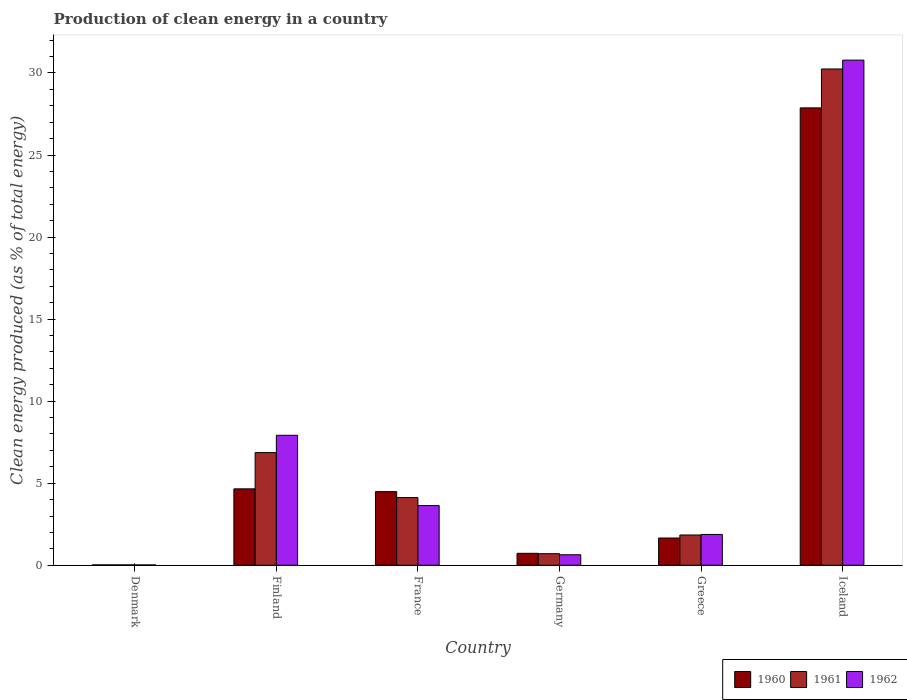How many different coloured bars are there?
Your answer should be very brief. 3. Are the number of bars on each tick of the X-axis equal?
Your response must be concise. Yes. What is the percentage of clean energy produced in 1960 in Germany?
Make the answer very short. 0.73. Across all countries, what is the maximum percentage of clean energy produced in 1960?
Your answer should be compact. 27.87. Across all countries, what is the minimum percentage of clean energy produced in 1960?
Ensure brevity in your answer.  0.02. What is the total percentage of clean energy produced in 1961 in the graph?
Keep it short and to the point. 43.81. What is the difference between the percentage of clean energy produced in 1960 in Finland and that in Iceland?
Your response must be concise. -23.22. What is the difference between the percentage of clean energy produced in 1962 in Greece and the percentage of clean energy produced in 1960 in Denmark?
Your response must be concise. 1.85. What is the average percentage of clean energy produced in 1960 per country?
Give a very brief answer. 6.57. What is the difference between the percentage of clean energy produced of/in 1962 and percentage of clean energy produced of/in 1961 in Denmark?
Give a very brief answer. -0. What is the ratio of the percentage of clean energy produced in 1962 in Denmark to that in Greece?
Give a very brief answer. 0.01. Is the percentage of clean energy produced in 1961 in Denmark less than that in France?
Keep it short and to the point. Yes. What is the difference between the highest and the second highest percentage of clean energy produced in 1962?
Provide a short and direct response. -27.15. What is the difference between the highest and the lowest percentage of clean energy produced in 1962?
Provide a short and direct response. 30.76. Is the sum of the percentage of clean energy produced in 1962 in Denmark and Iceland greater than the maximum percentage of clean energy produced in 1961 across all countries?
Offer a terse response. Yes. What does the 1st bar from the right in Greece represents?
Your answer should be compact. 1962. Is it the case that in every country, the sum of the percentage of clean energy produced in 1961 and percentage of clean energy produced in 1960 is greater than the percentage of clean energy produced in 1962?
Provide a short and direct response. Yes. Are all the bars in the graph horizontal?
Offer a very short reply. No. Are the values on the major ticks of Y-axis written in scientific E-notation?
Offer a terse response. No. Where does the legend appear in the graph?
Provide a short and direct response. Bottom right. How many legend labels are there?
Your answer should be very brief. 3. What is the title of the graph?
Offer a very short reply. Production of clean energy in a country. What is the label or title of the Y-axis?
Ensure brevity in your answer.  Clean energy produced (as % of total energy). What is the Clean energy produced (as % of total energy) in 1960 in Denmark?
Ensure brevity in your answer.  0.02. What is the Clean energy produced (as % of total energy) of 1961 in Denmark?
Your answer should be very brief. 0.02. What is the Clean energy produced (as % of total energy) in 1962 in Denmark?
Offer a very short reply. 0.02. What is the Clean energy produced (as % of total energy) of 1960 in Finland?
Keep it short and to the point. 4.66. What is the Clean energy produced (as % of total energy) of 1961 in Finland?
Offer a very short reply. 6.87. What is the Clean energy produced (as % of total energy) in 1962 in Finland?
Your answer should be compact. 7.92. What is the Clean energy produced (as % of total energy) of 1960 in France?
Make the answer very short. 4.49. What is the Clean energy produced (as % of total energy) of 1961 in France?
Your response must be concise. 4.12. What is the Clean energy produced (as % of total energy) in 1962 in France?
Your answer should be very brief. 3.64. What is the Clean energy produced (as % of total energy) of 1960 in Germany?
Offer a very short reply. 0.73. What is the Clean energy produced (as % of total energy) in 1961 in Germany?
Offer a terse response. 0.7. What is the Clean energy produced (as % of total energy) of 1962 in Germany?
Keep it short and to the point. 0.64. What is the Clean energy produced (as % of total energy) in 1960 in Greece?
Your answer should be very brief. 1.66. What is the Clean energy produced (as % of total energy) in 1961 in Greece?
Give a very brief answer. 1.84. What is the Clean energy produced (as % of total energy) in 1962 in Greece?
Offer a terse response. 1.88. What is the Clean energy produced (as % of total energy) of 1960 in Iceland?
Your answer should be compact. 27.87. What is the Clean energy produced (as % of total energy) in 1961 in Iceland?
Offer a very short reply. 30.24. What is the Clean energy produced (as % of total energy) of 1962 in Iceland?
Offer a very short reply. 30.78. Across all countries, what is the maximum Clean energy produced (as % of total energy) of 1960?
Offer a terse response. 27.87. Across all countries, what is the maximum Clean energy produced (as % of total energy) in 1961?
Provide a short and direct response. 30.24. Across all countries, what is the maximum Clean energy produced (as % of total energy) in 1962?
Ensure brevity in your answer.  30.78. Across all countries, what is the minimum Clean energy produced (as % of total energy) of 1960?
Your answer should be very brief. 0.02. Across all countries, what is the minimum Clean energy produced (as % of total energy) of 1961?
Provide a succinct answer. 0.02. Across all countries, what is the minimum Clean energy produced (as % of total energy) of 1962?
Give a very brief answer. 0.02. What is the total Clean energy produced (as % of total energy) of 1960 in the graph?
Make the answer very short. 39.43. What is the total Clean energy produced (as % of total energy) of 1961 in the graph?
Provide a short and direct response. 43.81. What is the total Clean energy produced (as % of total energy) of 1962 in the graph?
Make the answer very short. 44.88. What is the difference between the Clean energy produced (as % of total energy) of 1960 in Denmark and that in Finland?
Give a very brief answer. -4.63. What is the difference between the Clean energy produced (as % of total energy) in 1961 in Denmark and that in Finland?
Your response must be concise. -6.84. What is the difference between the Clean energy produced (as % of total energy) in 1962 in Denmark and that in Finland?
Make the answer very short. -7.9. What is the difference between the Clean energy produced (as % of total energy) in 1960 in Denmark and that in France?
Ensure brevity in your answer.  -4.46. What is the difference between the Clean energy produced (as % of total energy) of 1961 in Denmark and that in France?
Your answer should be compact. -4.1. What is the difference between the Clean energy produced (as % of total energy) of 1962 in Denmark and that in France?
Give a very brief answer. -3.62. What is the difference between the Clean energy produced (as % of total energy) in 1960 in Denmark and that in Germany?
Your answer should be very brief. -0.7. What is the difference between the Clean energy produced (as % of total energy) of 1961 in Denmark and that in Germany?
Provide a short and direct response. -0.68. What is the difference between the Clean energy produced (as % of total energy) in 1962 in Denmark and that in Germany?
Make the answer very short. -0.62. What is the difference between the Clean energy produced (as % of total energy) in 1960 in Denmark and that in Greece?
Ensure brevity in your answer.  -1.64. What is the difference between the Clean energy produced (as % of total energy) of 1961 in Denmark and that in Greece?
Keep it short and to the point. -1.82. What is the difference between the Clean energy produced (as % of total energy) in 1962 in Denmark and that in Greece?
Provide a short and direct response. -1.86. What is the difference between the Clean energy produced (as % of total energy) in 1960 in Denmark and that in Iceland?
Offer a terse response. -27.85. What is the difference between the Clean energy produced (as % of total energy) in 1961 in Denmark and that in Iceland?
Your answer should be compact. -30.22. What is the difference between the Clean energy produced (as % of total energy) in 1962 in Denmark and that in Iceland?
Your answer should be compact. -30.76. What is the difference between the Clean energy produced (as % of total energy) of 1960 in Finland and that in France?
Your response must be concise. 0.17. What is the difference between the Clean energy produced (as % of total energy) in 1961 in Finland and that in France?
Provide a short and direct response. 2.74. What is the difference between the Clean energy produced (as % of total energy) in 1962 in Finland and that in France?
Provide a short and direct response. 4.28. What is the difference between the Clean energy produced (as % of total energy) in 1960 in Finland and that in Germany?
Provide a succinct answer. 3.93. What is the difference between the Clean energy produced (as % of total energy) in 1961 in Finland and that in Germany?
Offer a terse response. 6.16. What is the difference between the Clean energy produced (as % of total energy) in 1962 in Finland and that in Germany?
Your response must be concise. 7.28. What is the difference between the Clean energy produced (as % of total energy) of 1960 in Finland and that in Greece?
Your response must be concise. 3. What is the difference between the Clean energy produced (as % of total energy) in 1961 in Finland and that in Greece?
Your answer should be very brief. 5.02. What is the difference between the Clean energy produced (as % of total energy) in 1962 in Finland and that in Greece?
Provide a succinct answer. 6.04. What is the difference between the Clean energy produced (as % of total energy) of 1960 in Finland and that in Iceland?
Your answer should be very brief. -23.22. What is the difference between the Clean energy produced (as % of total energy) in 1961 in Finland and that in Iceland?
Offer a terse response. -23.38. What is the difference between the Clean energy produced (as % of total energy) of 1962 in Finland and that in Iceland?
Keep it short and to the point. -22.86. What is the difference between the Clean energy produced (as % of total energy) in 1960 in France and that in Germany?
Your response must be concise. 3.76. What is the difference between the Clean energy produced (as % of total energy) of 1961 in France and that in Germany?
Ensure brevity in your answer.  3.42. What is the difference between the Clean energy produced (as % of total energy) in 1962 in France and that in Germany?
Your answer should be very brief. 3. What is the difference between the Clean energy produced (as % of total energy) of 1960 in France and that in Greece?
Provide a succinct answer. 2.83. What is the difference between the Clean energy produced (as % of total energy) in 1961 in France and that in Greece?
Provide a succinct answer. 2.28. What is the difference between the Clean energy produced (as % of total energy) in 1962 in France and that in Greece?
Your response must be concise. 1.76. What is the difference between the Clean energy produced (as % of total energy) of 1960 in France and that in Iceland?
Give a very brief answer. -23.39. What is the difference between the Clean energy produced (as % of total energy) of 1961 in France and that in Iceland?
Your answer should be compact. -26.12. What is the difference between the Clean energy produced (as % of total energy) of 1962 in France and that in Iceland?
Offer a very short reply. -27.15. What is the difference between the Clean energy produced (as % of total energy) of 1960 in Germany and that in Greece?
Your answer should be very brief. -0.93. What is the difference between the Clean energy produced (as % of total energy) in 1961 in Germany and that in Greece?
Your answer should be very brief. -1.14. What is the difference between the Clean energy produced (as % of total energy) of 1962 in Germany and that in Greece?
Provide a succinct answer. -1.24. What is the difference between the Clean energy produced (as % of total energy) in 1960 in Germany and that in Iceland?
Your answer should be compact. -27.14. What is the difference between the Clean energy produced (as % of total energy) in 1961 in Germany and that in Iceland?
Offer a very short reply. -29.54. What is the difference between the Clean energy produced (as % of total energy) in 1962 in Germany and that in Iceland?
Ensure brevity in your answer.  -30.14. What is the difference between the Clean energy produced (as % of total energy) of 1960 in Greece and that in Iceland?
Ensure brevity in your answer.  -26.21. What is the difference between the Clean energy produced (as % of total energy) of 1961 in Greece and that in Iceland?
Provide a short and direct response. -28.4. What is the difference between the Clean energy produced (as % of total energy) of 1962 in Greece and that in Iceland?
Offer a terse response. -28.9. What is the difference between the Clean energy produced (as % of total energy) of 1960 in Denmark and the Clean energy produced (as % of total energy) of 1961 in Finland?
Your answer should be compact. -6.84. What is the difference between the Clean energy produced (as % of total energy) in 1960 in Denmark and the Clean energy produced (as % of total energy) in 1962 in Finland?
Your response must be concise. -7.9. What is the difference between the Clean energy produced (as % of total energy) in 1961 in Denmark and the Clean energy produced (as % of total energy) in 1962 in Finland?
Give a very brief answer. -7.9. What is the difference between the Clean energy produced (as % of total energy) in 1960 in Denmark and the Clean energy produced (as % of total energy) in 1961 in France?
Provide a short and direct response. -4.1. What is the difference between the Clean energy produced (as % of total energy) of 1960 in Denmark and the Clean energy produced (as % of total energy) of 1962 in France?
Make the answer very short. -3.61. What is the difference between the Clean energy produced (as % of total energy) of 1961 in Denmark and the Clean energy produced (as % of total energy) of 1962 in France?
Give a very brief answer. -3.61. What is the difference between the Clean energy produced (as % of total energy) in 1960 in Denmark and the Clean energy produced (as % of total energy) in 1961 in Germany?
Offer a very short reply. -0.68. What is the difference between the Clean energy produced (as % of total energy) of 1960 in Denmark and the Clean energy produced (as % of total energy) of 1962 in Germany?
Offer a very short reply. -0.62. What is the difference between the Clean energy produced (as % of total energy) of 1961 in Denmark and the Clean energy produced (as % of total energy) of 1962 in Germany?
Offer a very short reply. -0.62. What is the difference between the Clean energy produced (as % of total energy) of 1960 in Denmark and the Clean energy produced (as % of total energy) of 1961 in Greece?
Offer a terse response. -1.82. What is the difference between the Clean energy produced (as % of total energy) of 1960 in Denmark and the Clean energy produced (as % of total energy) of 1962 in Greece?
Provide a succinct answer. -1.85. What is the difference between the Clean energy produced (as % of total energy) in 1961 in Denmark and the Clean energy produced (as % of total energy) in 1962 in Greece?
Offer a terse response. -1.85. What is the difference between the Clean energy produced (as % of total energy) of 1960 in Denmark and the Clean energy produced (as % of total energy) of 1961 in Iceland?
Offer a very short reply. -30.22. What is the difference between the Clean energy produced (as % of total energy) of 1960 in Denmark and the Clean energy produced (as % of total energy) of 1962 in Iceland?
Ensure brevity in your answer.  -30.76. What is the difference between the Clean energy produced (as % of total energy) of 1961 in Denmark and the Clean energy produced (as % of total energy) of 1962 in Iceland?
Make the answer very short. -30.76. What is the difference between the Clean energy produced (as % of total energy) in 1960 in Finland and the Clean energy produced (as % of total energy) in 1961 in France?
Offer a terse response. 0.53. What is the difference between the Clean energy produced (as % of total energy) in 1960 in Finland and the Clean energy produced (as % of total energy) in 1962 in France?
Offer a very short reply. 1.02. What is the difference between the Clean energy produced (as % of total energy) in 1961 in Finland and the Clean energy produced (as % of total energy) in 1962 in France?
Provide a short and direct response. 3.23. What is the difference between the Clean energy produced (as % of total energy) of 1960 in Finland and the Clean energy produced (as % of total energy) of 1961 in Germany?
Offer a very short reply. 3.95. What is the difference between the Clean energy produced (as % of total energy) of 1960 in Finland and the Clean energy produced (as % of total energy) of 1962 in Germany?
Offer a very short reply. 4.02. What is the difference between the Clean energy produced (as % of total energy) in 1961 in Finland and the Clean energy produced (as % of total energy) in 1962 in Germany?
Keep it short and to the point. 6.23. What is the difference between the Clean energy produced (as % of total energy) in 1960 in Finland and the Clean energy produced (as % of total energy) in 1961 in Greece?
Make the answer very short. 2.81. What is the difference between the Clean energy produced (as % of total energy) in 1960 in Finland and the Clean energy produced (as % of total energy) in 1962 in Greece?
Ensure brevity in your answer.  2.78. What is the difference between the Clean energy produced (as % of total energy) in 1961 in Finland and the Clean energy produced (as % of total energy) in 1962 in Greece?
Your response must be concise. 4.99. What is the difference between the Clean energy produced (as % of total energy) of 1960 in Finland and the Clean energy produced (as % of total energy) of 1961 in Iceland?
Your answer should be very brief. -25.59. What is the difference between the Clean energy produced (as % of total energy) of 1960 in Finland and the Clean energy produced (as % of total energy) of 1962 in Iceland?
Make the answer very short. -26.13. What is the difference between the Clean energy produced (as % of total energy) of 1961 in Finland and the Clean energy produced (as % of total energy) of 1962 in Iceland?
Your answer should be compact. -23.92. What is the difference between the Clean energy produced (as % of total energy) of 1960 in France and the Clean energy produced (as % of total energy) of 1961 in Germany?
Give a very brief answer. 3.78. What is the difference between the Clean energy produced (as % of total energy) of 1960 in France and the Clean energy produced (as % of total energy) of 1962 in Germany?
Provide a succinct answer. 3.85. What is the difference between the Clean energy produced (as % of total energy) in 1961 in France and the Clean energy produced (as % of total energy) in 1962 in Germany?
Provide a succinct answer. 3.48. What is the difference between the Clean energy produced (as % of total energy) in 1960 in France and the Clean energy produced (as % of total energy) in 1961 in Greece?
Offer a terse response. 2.64. What is the difference between the Clean energy produced (as % of total energy) in 1960 in France and the Clean energy produced (as % of total energy) in 1962 in Greece?
Ensure brevity in your answer.  2.61. What is the difference between the Clean energy produced (as % of total energy) in 1961 in France and the Clean energy produced (as % of total energy) in 1962 in Greece?
Make the answer very short. 2.25. What is the difference between the Clean energy produced (as % of total energy) in 1960 in France and the Clean energy produced (as % of total energy) in 1961 in Iceland?
Provide a succinct answer. -25.76. What is the difference between the Clean energy produced (as % of total energy) of 1960 in France and the Clean energy produced (as % of total energy) of 1962 in Iceland?
Make the answer very short. -26.3. What is the difference between the Clean energy produced (as % of total energy) of 1961 in France and the Clean energy produced (as % of total energy) of 1962 in Iceland?
Provide a short and direct response. -26.66. What is the difference between the Clean energy produced (as % of total energy) of 1960 in Germany and the Clean energy produced (as % of total energy) of 1961 in Greece?
Ensure brevity in your answer.  -1.12. What is the difference between the Clean energy produced (as % of total energy) of 1960 in Germany and the Clean energy produced (as % of total energy) of 1962 in Greece?
Keep it short and to the point. -1.15. What is the difference between the Clean energy produced (as % of total energy) of 1961 in Germany and the Clean energy produced (as % of total energy) of 1962 in Greece?
Offer a terse response. -1.17. What is the difference between the Clean energy produced (as % of total energy) in 1960 in Germany and the Clean energy produced (as % of total energy) in 1961 in Iceland?
Give a very brief answer. -29.52. What is the difference between the Clean energy produced (as % of total energy) in 1960 in Germany and the Clean energy produced (as % of total energy) in 1962 in Iceland?
Provide a short and direct response. -30.05. What is the difference between the Clean energy produced (as % of total energy) in 1961 in Germany and the Clean energy produced (as % of total energy) in 1962 in Iceland?
Your response must be concise. -30.08. What is the difference between the Clean energy produced (as % of total energy) in 1960 in Greece and the Clean energy produced (as % of total energy) in 1961 in Iceland?
Keep it short and to the point. -28.58. What is the difference between the Clean energy produced (as % of total energy) of 1960 in Greece and the Clean energy produced (as % of total energy) of 1962 in Iceland?
Provide a short and direct response. -29.12. What is the difference between the Clean energy produced (as % of total energy) in 1961 in Greece and the Clean energy produced (as % of total energy) in 1962 in Iceland?
Offer a terse response. -28.94. What is the average Clean energy produced (as % of total energy) in 1960 per country?
Keep it short and to the point. 6.57. What is the average Clean energy produced (as % of total energy) in 1961 per country?
Ensure brevity in your answer.  7.3. What is the average Clean energy produced (as % of total energy) in 1962 per country?
Offer a very short reply. 7.48. What is the difference between the Clean energy produced (as % of total energy) in 1960 and Clean energy produced (as % of total energy) in 1962 in Denmark?
Your answer should be very brief. 0. What is the difference between the Clean energy produced (as % of total energy) in 1961 and Clean energy produced (as % of total energy) in 1962 in Denmark?
Your answer should be very brief. 0. What is the difference between the Clean energy produced (as % of total energy) in 1960 and Clean energy produced (as % of total energy) in 1961 in Finland?
Your response must be concise. -2.21. What is the difference between the Clean energy produced (as % of total energy) of 1960 and Clean energy produced (as % of total energy) of 1962 in Finland?
Your answer should be very brief. -3.26. What is the difference between the Clean energy produced (as % of total energy) in 1961 and Clean energy produced (as % of total energy) in 1962 in Finland?
Make the answer very short. -1.06. What is the difference between the Clean energy produced (as % of total energy) of 1960 and Clean energy produced (as % of total energy) of 1961 in France?
Give a very brief answer. 0.36. What is the difference between the Clean energy produced (as % of total energy) of 1960 and Clean energy produced (as % of total energy) of 1962 in France?
Keep it short and to the point. 0.85. What is the difference between the Clean energy produced (as % of total energy) of 1961 and Clean energy produced (as % of total energy) of 1962 in France?
Keep it short and to the point. 0.49. What is the difference between the Clean energy produced (as % of total energy) of 1960 and Clean energy produced (as % of total energy) of 1961 in Germany?
Keep it short and to the point. 0.02. What is the difference between the Clean energy produced (as % of total energy) of 1960 and Clean energy produced (as % of total energy) of 1962 in Germany?
Provide a short and direct response. 0.09. What is the difference between the Clean energy produced (as % of total energy) of 1961 and Clean energy produced (as % of total energy) of 1962 in Germany?
Your answer should be very brief. 0.06. What is the difference between the Clean energy produced (as % of total energy) of 1960 and Clean energy produced (as % of total energy) of 1961 in Greece?
Keep it short and to the point. -0.18. What is the difference between the Clean energy produced (as % of total energy) of 1960 and Clean energy produced (as % of total energy) of 1962 in Greece?
Make the answer very short. -0.22. What is the difference between the Clean energy produced (as % of total energy) in 1961 and Clean energy produced (as % of total energy) in 1962 in Greece?
Give a very brief answer. -0.03. What is the difference between the Clean energy produced (as % of total energy) of 1960 and Clean energy produced (as % of total energy) of 1961 in Iceland?
Make the answer very short. -2.37. What is the difference between the Clean energy produced (as % of total energy) of 1960 and Clean energy produced (as % of total energy) of 1962 in Iceland?
Ensure brevity in your answer.  -2.91. What is the difference between the Clean energy produced (as % of total energy) of 1961 and Clean energy produced (as % of total energy) of 1962 in Iceland?
Your response must be concise. -0.54. What is the ratio of the Clean energy produced (as % of total energy) of 1960 in Denmark to that in Finland?
Keep it short and to the point. 0.01. What is the ratio of the Clean energy produced (as % of total energy) of 1961 in Denmark to that in Finland?
Keep it short and to the point. 0. What is the ratio of the Clean energy produced (as % of total energy) of 1962 in Denmark to that in Finland?
Provide a short and direct response. 0. What is the ratio of the Clean energy produced (as % of total energy) of 1960 in Denmark to that in France?
Provide a short and direct response. 0.01. What is the ratio of the Clean energy produced (as % of total energy) in 1961 in Denmark to that in France?
Make the answer very short. 0.01. What is the ratio of the Clean energy produced (as % of total energy) in 1962 in Denmark to that in France?
Your answer should be very brief. 0.01. What is the ratio of the Clean energy produced (as % of total energy) in 1960 in Denmark to that in Germany?
Ensure brevity in your answer.  0.03. What is the ratio of the Clean energy produced (as % of total energy) of 1961 in Denmark to that in Germany?
Your answer should be very brief. 0.03. What is the ratio of the Clean energy produced (as % of total energy) in 1962 in Denmark to that in Germany?
Give a very brief answer. 0.03. What is the ratio of the Clean energy produced (as % of total energy) in 1960 in Denmark to that in Greece?
Offer a terse response. 0.01. What is the ratio of the Clean energy produced (as % of total energy) of 1961 in Denmark to that in Greece?
Make the answer very short. 0.01. What is the ratio of the Clean energy produced (as % of total energy) in 1962 in Denmark to that in Greece?
Offer a terse response. 0.01. What is the ratio of the Clean energy produced (as % of total energy) in 1960 in Denmark to that in Iceland?
Provide a short and direct response. 0. What is the ratio of the Clean energy produced (as % of total energy) of 1961 in Denmark to that in Iceland?
Offer a very short reply. 0. What is the ratio of the Clean energy produced (as % of total energy) of 1962 in Denmark to that in Iceland?
Give a very brief answer. 0. What is the ratio of the Clean energy produced (as % of total energy) in 1960 in Finland to that in France?
Offer a very short reply. 1.04. What is the ratio of the Clean energy produced (as % of total energy) in 1961 in Finland to that in France?
Keep it short and to the point. 1.66. What is the ratio of the Clean energy produced (as % of total energy) in 1962 in Finland to that in France?
Provide a short and direct response. 2.18. What is the ratio of the Clean energy produced (as % of total energy) in 1960 in Finland to that in Germany?
Keep it short and to the point. 6.4. What is the ratio of the Clean energy produced (as % of total energy) of 1961 in Finland to that in Germany?
Ensure brevity in your answer.  9.74. What is the ratio of the Clean energy produced (as % of total energy) in 1962 in Finland to that in Germany?
Ensure brevity in your answer.  12.37. What is the ratio of the Clean energy produced (as % of total energy) of 1960 in Finland to that in Greece?
Your answer should be compact. 2.8. What is the ratio of the Clean energy produced (as % of total energy) of 1961 in Finland to that in Greece?
Your answer should be compact. 3.72. What is the ratio of the Clean energy produced (as % of total energy) in 1962 in Finland to that in Greece?
Offer a very short reply. 4.22. What is the ratio of the Clean energy produced (as % of total energy) of 1960 in Finland to that in Iceland?
Offer a very short reply. 0.17. What is the ratio of the Clean energy produced (as % of total energy) of 1961 in Finland to that in Iceland?
Ensure brevity in your answer.  0.23. What is the ratio of the Clean energy produced (as % of total energy) in 1962 in Finland to that in Iceland?
Your answer should be very brief. 0.26. What is the ratio of the Clean energy produced (as % of total energy) of 1960 in France to that in Germany?
Ensure brevity in your answer.  6.16. What is the ratio of the Clean energy produced (as % of total energy) in 1961 in France to that in Germany?
Your answer should be compact. 5.85. What is the ratio of the Clean energy produced (as % of total energy) in 1962 in France to that in Germany?
Make the answer very short. 5.68. What is the ratio of the Clean energy produced (as % of total energy) in 1960 in France to that in Greece?
Your response must be concise. 2.7. What is the ratio of the Clean energy produced (as % of total energy) in 1961 in France to that in Greece?
Ensure brevity in your answer.  2.24. What is the ratio of the Clean energy produced (as % of total energy) of 1962 in France to that in Greece?
Your answer should be compact. 1.94. What is the ratio of the Clean energy produced (as % of total energy) in 1960 in France to that in Iceland?
Offer a terse response. 0.16. What is the ratio of the Clean energy produced (as % of total energy) of 1961 in France to that in Iceland?
Ensure brevity in your answer.  0.14. What is the ratio of the Clean energy produced (as % of total energy) of 1962 in France to that in Iceland?
Make the answer very short. 0.12. What is the ratio of the Clean energy produced (as % of total energy) of 1960 in Germany to that in Greece?
Your answer should be compact. 0.44. What is the ratio of the Clean energy produced (as % of total energy) in 1961 in Germany to that in Greece?
Keep it short and to the point. 0.38. What is the ratio of the Clean energy produced (as % of total energy) of 1962 in Germany to that in Greece?
Offer a terse response. 0.34. What is the ratio of the Clean energy produced (as % of total energy) in 1960 in Germany to that in Iceland?
Ensure brevity in your answer.  0.03. What is the ratio of the Clean energy produced (as % of total energy) in 1961 in Germany to that in Iceland?
Offer a very short reply. 0.02. What is the ratio of the Clean energy produced (as % of total energy) in 1962 in Germany to that in Iceland?
Give a very brief answer. 0.02. What is the ratio of the Clean energy produced (as % of total energy) of 1960 in Greece to that in Iceland?
Give a very brief answer. 0.06. What is the ratio of the Clean energy produced (as % of total energy) in 1961 in Greece to that in Iceland?
Provide a succinct answer. 0.06. What is the ratio of the Clean energy produced (as % of total energy) of 1962 in Greece to that in Iceland?
Ensure brevity in your answer.  0.06. What is the difference between the highest and the second highest Clean energy produced (as % of total energy) of 1960?
Your response must be concise. 23.22. What is the difference between the highest and the second highest Clean energy produced (as % of total energy) of 1961?
Give a very brief answer. 23.38. What is the difference between the highest and the second highest Clean energy produced (as % of total energy) of 1962?
Your answer should be compact. 22.86. What is the difference between the highest and the lowest Clean energy produced (as % of total energy) in 1960?
Give a very brief answer. 27.85. What is the difference between the highest and the lowest Clean energy produced (as % of total energy) in 1961?
Make the answer very short. 30.22. What is the difference between the highest and the lowest Clean energy produced (as % of total energy) of 1962?
Provide a succinct answer. 30.76. 